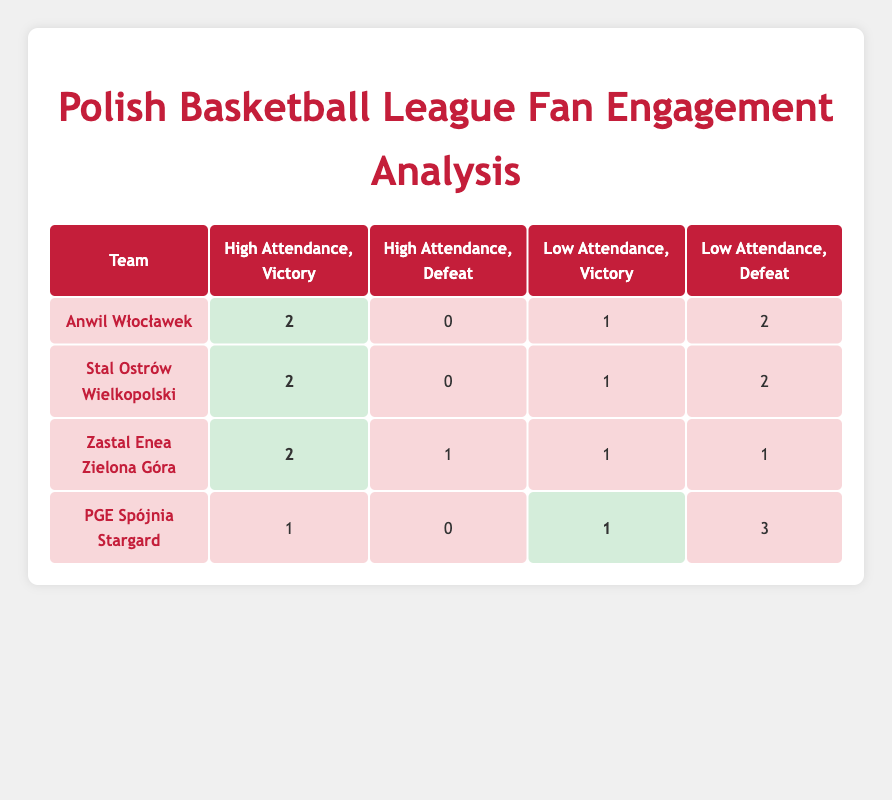What is the number of games with high attendance and victories for Anwil Włocławek? In the table, look at the row for Anwil Włocławek under the column "High Attendance, Victory." The value in that cell is 2.
Answer: 2 How many games did PGE Spójnia Stargard win while having low attendance? In the row for PGE Spójnia Stargard, check the column "Low Attendance, Victory." The value in that cell is 1.
Answer: 1 Which team has the most losses when having low attendance? In the table, we need to look at the "Low Attendance, Defeat" column for each team. PGE Spójnia Stargard has 3 defeats in this category, which is the highest.
Answer: PGE Spójnia Stargard What is the total number of high attendance victories across all teams? To find this, we sum up the values in the "High Attendance, Victory" column for all teams: Anwil Włocławek (2) + Stal Ostrów Wielkopolski (2) + Zastal Enea Zielona Góra (2) + PGE Spójnia Stargard (0) = 6.
Answer: 6 Is it true that Zastal Enea Zielona Góra had more high attendance victories than low attendance victories? First, look at the "High Attendance, Victory" column for Zastal Enea Zielona Góra, which has a value of 2. Then check "Low Attendance, Victory," which has a value of 1. Since 2 is greater than 1, the statement is true.
Answer: Yes How many teams had a high attendance victory rate of 2? We can see that Anwil Włocławek, Stal Ostrów Wielkopolski, and Zastal Enea Zielona Góra each had 2 high attendance victories. This means there are 3 teams.
Answer: 3 What is the difference in low attendance defeats between Zastal Enea Zielona Góra and PGE Spójnia Stargard? For Zastal Enea Zielona Góra, the "Low Attendance, Defeat" value is 1. For PGE Spójnia Stargard, the value is 3. The difference is 3 - 1 = 2.
Answer: 2 Which team has the highest number of total defeats? We need to calculate total defeats for each team: Anwil Włocławek (2 + 0 = 2), Stal Ostrów Wielkopolski (2 + 0 = 2), Zastal Enea Zielona Góra (1 + 1 = 2), PGE Spójnia Stargard (0 + 3 = 3). PGE Spójnia Stargard has the highest total defeats.
Answer: PGE Spójnia Stargard 